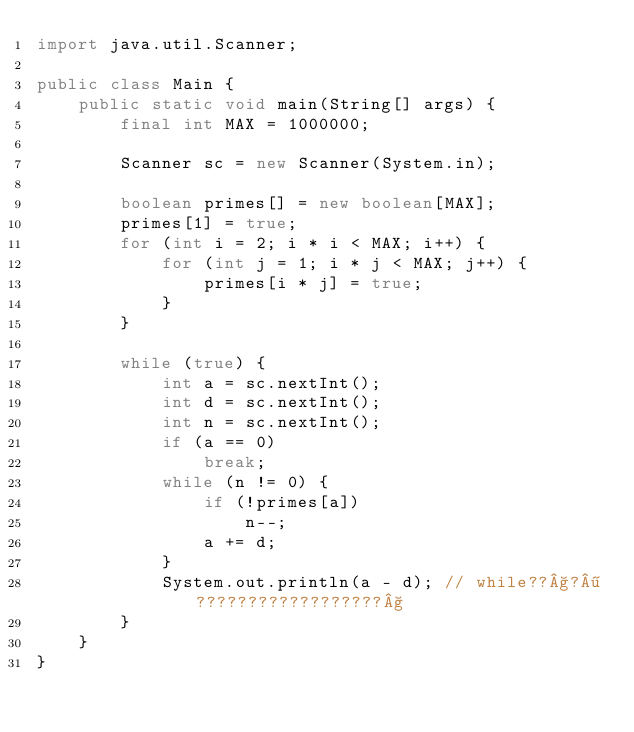<code> <loc_0><loc_0><loc_500><loc_500><_Java_>import java.util.Scanner;

public class Main {
	public static void main(String[] args) {
		final int MAX = 1000000;

		Scanner sc = new Scanner(System.in);

		boolean primes[] = new boolean[MAX];
		primes[1] = true;
		for (int i = 2; i * i < MAX; i++) {
			for (int j = 1; i * j < MAX; j++) {
				primes[i * j] = true;
			}
		}

		while (true) {
			int a = sc.nextInt();
			int d = sc.nextInt();
			int n = sc.nextInt();
			if (a == 0)
				break;
			while (n != 0) {
				if (!primes[a])
					n--;
				a += d;
			}
			System.out.println(a - d); // while??§?¶??????????????????§
		}
	}
}</code> 